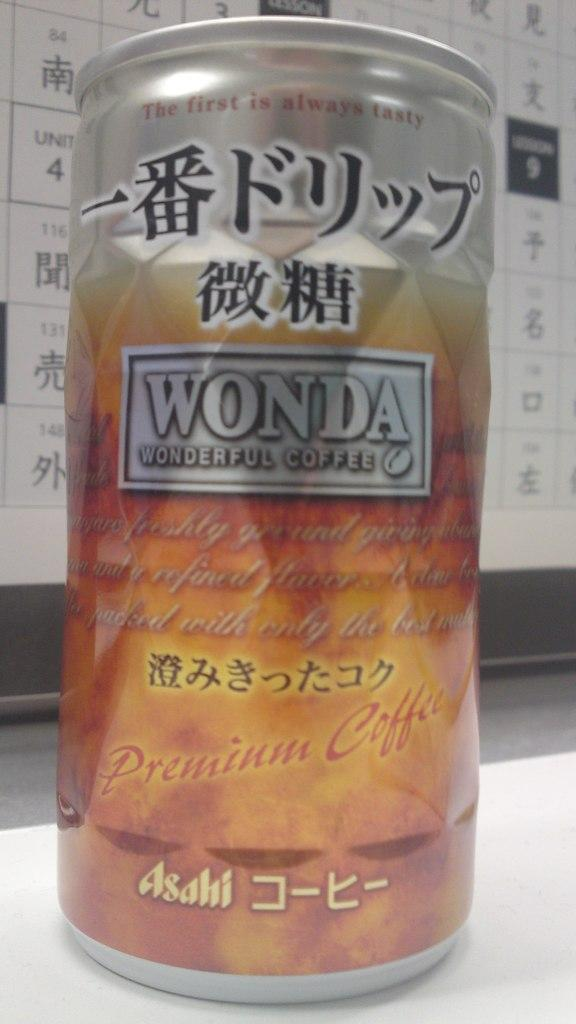<image>
Offer a succinct explanation of the picture presented. A can of Wonda coffee with kanji writing 